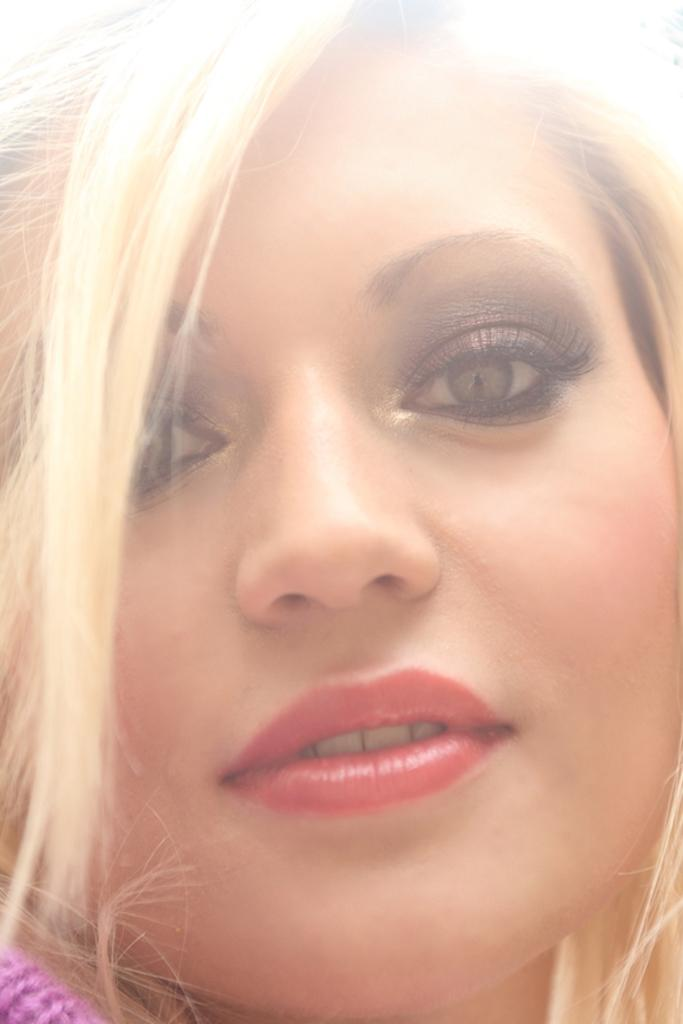What is the main subject of the image? The main subject of the image is a woman. Can you describe the woman's appearance? The woman has blonde hair. Where is the cactus located in the image? There is no cactus present in the image. What type of throne does the woman sit on in the image? There is no throne present in the image; it only features a woman with blonde hair. 